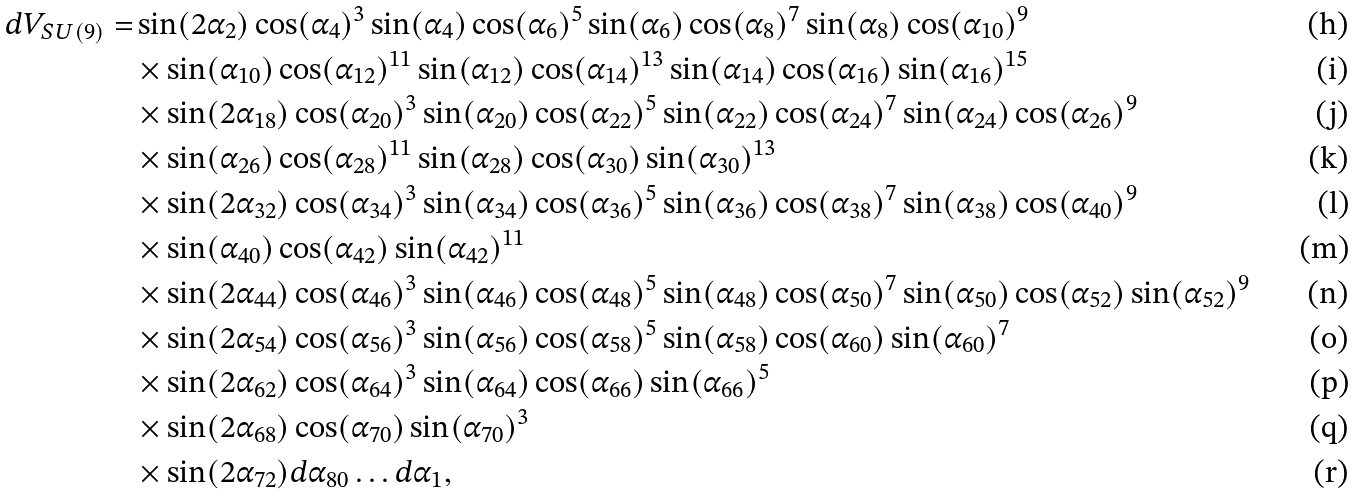<formula> <loc_0><loc_0><loc_500><loc_500>d V _ { S U ( 9 ) } = & \sin ( 2 \alpha _ { 2 } ) \cos ( \alpha _ { 4 } ) ^ { 3 } \sin ( \alpha _ { 4 } ) \cos ( \alpha _ { 6 } ) ^ { 5 } \sin ( \alpha _ { 6 } ) \cos ( \alpha _ { 8 } ) ^ { 7 } \sin ( \alpha _ { 8 } ) \cos ( \alpha _ { 1 0 } ) ^ { 9 } \\ & \times \sin ( \alpha _ { 1 0 } ) \cos ( \alpha _ { 1 2 } ) ^ { 1 1 } \sin ( \alpha _ { 1 2 } ) \cos ( \alpha _ { 1 4 } ) ^ { 1 3 } \sin ( \alpha _ { 1 4 } ) \cos ( \alpha _ { 1 6 } ) \sin ( \alpha _ { 1 6 } ) ^ { 1 5 } \\ & \times \sin ( 2 \alpha _ { 1 8 } ) \cos ( \alpha _ { 2 0 } ) ^ { 3 } \sin ( \alpha _ { 2 0 } ) \cos ( \alpha _ { 2 2 } ) ^ { 5 } \sin ( \alpha _ { 2 2 } ) \cos ( \alpha _ { 2 4 } ) ^ { 7 } \sin ( \alpha _ { 2 4 } ) \cos ( \alpha _ { 2 6 } ) ^ { 9 } \\ & \times \sin ( \alpha _ { 2 6 } ) \cos ( \alpha _ { 2 8 } ) ^ { 1 1 } \sin ( \alpha _ { 2 8 } ) \cos ( \alpha _ { 3 0 } ) \sin ( \alpha _ { 3 0 } ) ^ { 1 3 } \\ & \times \sin ( 2 \alpha _ { 3 2 } ) \cos ( \alpha _ { 3 4 } ) ^ { 3 } \sin ( \alpha _ { 3 4 } ) \cos ( \alpha _ { 3 6 } ) ^ { 5 } \sin ( \alpha _ { 3 6 } ) \cos ( \alpha _ { 3 8 } ) ^ { 7 } \sin ( \alpha _ { 3 8 } ) \cos ( \alpha _ { 4 0 } ) ^ { 9 } \\ & \times \sin ( \alpha _ { 4 0 } ) \cos ( \alpha _ { 4 2 } ) \sin ( \alpha _ { 4 2 } ) ^ { 1 1 } \\ & \times \sin ( 2 \alpha _ { 4 4 } ) \cos ( \alpha _ { 4 6 } ) ^ { 3 } \sin ( \alpha _ { 4 6 } ) \cos ( \alpha _ { 4 8 } ) ^ { 5 } \sin ( \alpha _ { 4 8 } ) \cos ( \alpha _ { 5 0 } ) ^ { 7 } \sin ( \alpha _ { 5 0 } ) \cos ( \alpha _ { 5 2 } ) \sin ( \alpha _ { 5 2 } ) ^ { 9 } \\ & \times \sin ( 2 \alpha _ { 5 4 } ) \cos ( \alpha _ { 5 6 } ) ^ { 3 } \sin ( \alpha _ { 5 6 } ) \cos ( \alpha _ { 5 8 } ) ^ { 5 } \sin ( \alpha _ { 5 8 } ) \cos ( \alpha _ { 6 0 } ) \sin ( \alpha _ { 6 0 } ) ^ { 7 } \\ & \times \sin ( 2 \alpha _ { 6 2 } ) \cos ( \alpha _ { 6 4 } ) ^ { 3 } \sin ( \alpha _ { 6 4 } ) \cos ( \alpha _ { 6 6 } ) \sin ( \alpha _ { 6 6 } ) ^ { 5 } \\ & \times \sin ( 2 \alpha _ { 6 8 } ) \cos ( \alpha _ { 7 0 } ) \sin ( \alpha _ { 7 0 } ) ^ { 3 } \\ & \times \sin ( 2 \alpha _ { 7 2 } ) d \alpha _ { 8 0 } \dots d \alpha _ { 1 } ,</formula> 